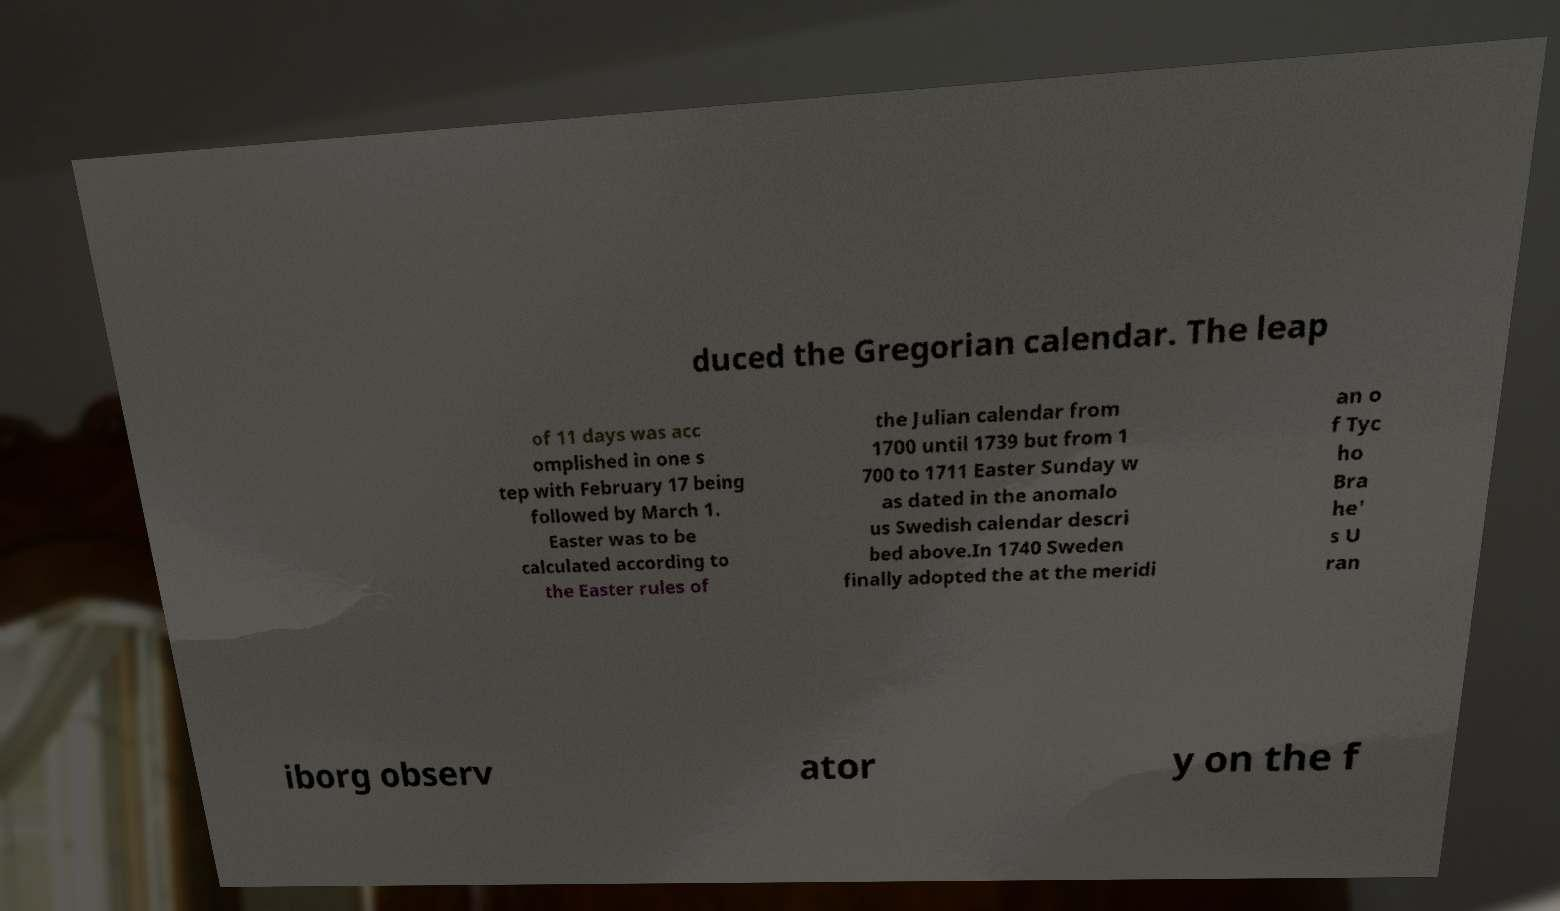Can you read and provide the text displayed in the image?This photo seems to have some interesting text. Can you extract and type it out for me? duced the Gregorian calendar. The leap of 11 days was acc omplished in one s tep with February 17 being followed by March 1. Easter was to be calculated according to the Easter rules of the Julian calendar from 1700 until 1739 but from 1 700 to 1711 Easter Sunday w as dated in the anomalo us Swedish calendar descri bed above.In 1740 Sweden finally adopted the at the meridi an o f Tyc ho Bra he' s U ran iborg observ ator y on the f 